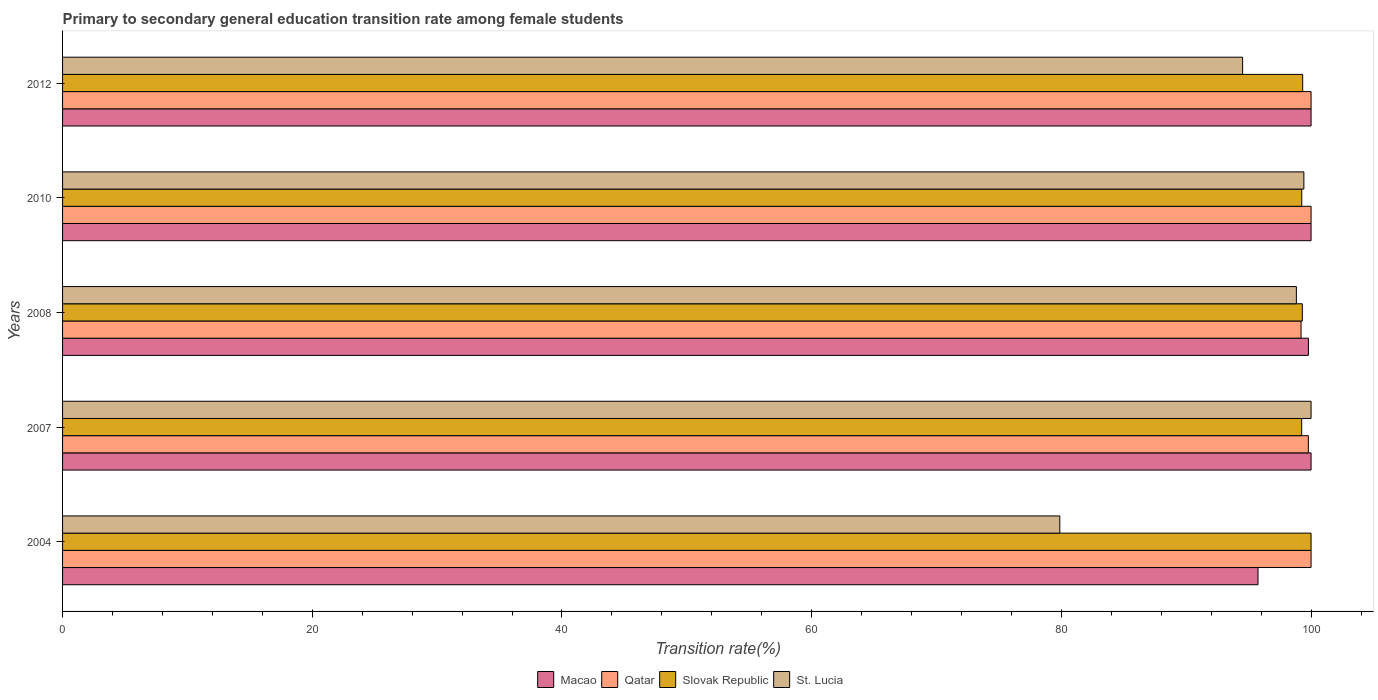Are the number of bars per tick equal to the number of legend labels?
Offer a very short reply. Yes. How many bars are there on the 1st tick from the top?
Your answer should be very brief. 4. How many bars are there on the 3rd tick from the bottom?
Provide a short and direct response. 4. What is the label of the 5th group of bars from the top?
Keep it short and to the point. 2004. In how many cases, is the number of bars for a given year not equal to the number of legend labels?
Your response must be concise. 0. What is the transition rate in Macao in 2012?
Your answer should be compact. 100. Across all years, what is the minimum transition rate in Qatar?
Ensure brevity in your answer.  99.2. In which year was the transition rate in Qatar minimum?
Offer a very short reply. 2008. What is the total transition rate in St. Lucia in the graph?
Offer a terse response. 472.64. What is the difference between the transition rate in St. Lucia in 2010 and the transition rate in Slovak Republic in 2008?
Your answer should be compact. 0.12. What is the average transition rate in St. Lucia per year?
Offer a terse response. 94.53. In the year 2010, what is the difference between the transition rate in Macao and transition rate in St. Lucia?
Make the answer very short. 0.58. In how many years, is the transition rate in Slovak Republic greater than 60 %?
Ensure brevity in your answer.  5. What is the ratio of the transition rate in St. Lucia in 2007 to that in 2010?
Ensure brevity in your answer.  1.01. What is the difference between the highest and the lowest transition rate in St. Lucia?
Give a very brief answer. 20.13. What does the 4th bar from the top in 2007 represents?
Your answer should be very brief. Macao. What does the 4th bar from the bottom in 2004 represents?
Provide a succinct answer. St. Lucia. Is it the case that in every year, the sum of the transition rate in Macao and transition rate in St. Lucia is greater than the transition rate in Qatar?
Offer a terse response. Yes. How many bars are there?
Keep it short and to the point. 20. Are the values on the major ticks of X-axis written in scientific E-notation?
Your answer should be very brief. No. Does the graph contain any zero values?
Your answer should be very brief. No. Where does the legend appear in the graph?
Your response must be concise. Bottom center. How many legend labels are there?
Offer a terse response. 4. How are the legend labels stacked?
Keep it short and to the point. Horizontal. What is the title of the graph?
Offer a very short reply. Primary to secondary general education transition rate among female students. What is the label or title of the X-axis?
Ensure brevity in your answer.  Transition rate(%). What is the label or title of the Y-axis?
Offer a terse response. Years. What is the Transition rate(%) in Macao in 2004?
Provide a short and direct response. 95.75. What is the Transition rate(%) in Slovak Republic in 2004?
Offer a very short reply. 100. What is the Transition rate(%) in St. Lucia in 2004?
Offer a very short reply. 79.87. What is the Transition rate(%) of Qatar in 2007?
Your response must be concise. 99.78. What is the Transition rate(%) in Slovak Republic in 2007?
Your answer should be very brief. 99.25. What is the Transition rate(%) in Macao in 2008?
Your answer should be very brief. 99.79. What is the Transition rate(%) in Qatar in 2008?
Provide a short and direct response. 99.2. What is the Transition rate(%) in Slovak Republic in 2008?
Your answer should be compact. 99.3. What is the Transition rate(%) of St. Lucia in 2008?
Your response must be concise. 98.82. What is the Transition rate(%) of Qatar in 2010?
Keep it short and to the point. 100. What is the Transition rate(%) in Slovak Republic in 2010?
Your answer should be compact. 99.25. What is the Transition rate(%) of St. Lucia in 2010?
Keep it short and to the point. 99.42. What is the Transition rate(%) in Qatar in 2012?
Offer a terse response. 100. What is the Transition rate(%) of Slovak Republic in 2012?
Make the answer very short. 99.33. What is the Transition rate(%) of St. Lucia in 2012?
Ensure brevity in your answer.  94.52. Across all years, what is the maximum Transition rate(%) in St. Lucia?
Offer a very short reply. 100. Across all years, what is the minimum Transition rate(%) of Macao?
Ensure brevity in your answer.  95.75. Across all years, what is the minimum Transition rate(%) of Qatar?
Offer a very short reply. 99.2. Across all years, what is the minimum Transition rate(%) in Slovak Republic?
Give a very brief answer. 99.25. Across all years, what is the minimum Transition rate(%) in St. Lucia?
Offer a terse response. 79.87. What is the total Transition rate(%) of Macao in the graph?
Offer a very short reply. 495.54. What is the total Transition rate(%) in Qatar in the graph?
Your answer should be very brief. 498.98. What is the total Transition rate(%) in Slovak Republic in the graph?
Provide a short and direct response. 497.13. What is the total Transition rate(%) in St. Lucia in the graph?
Your answer should be compact. 472.64. What is the difference between the Transition rate(%) in Macao in 2004 and that in 2007?
Your answer should be compact. -4.25. What is the difference between the Transition rate(%) of Qatar in 2004 and that in 2007?
Give a very brief answer. 0.22. What is the difference between the Transition rate(%) in Slovak Republic in 2004 and that in 2007?
Keep it short and to the point. 0.75. What is the difference between the Transition rate(%) of St. Lucia in 2004 and that in 2007?
Give a very brief answer. -20.13. What is the difference between the Transition rate(%) in Macao in 2004 and that in 2008?
Keep it short and to the point. -4.04. What is the difference between the Transition rate(%) of Qatar in 2004 and that in 2008?
Your answer should be compact. 0.8. What is the difference between the Transition rate(%) of Slovak Republic in 2004 and that in 2008?
Keep it short and to the point. 0.7. What is the difference between the Transition rate(%) of St. Lucia in 2004 and that in 2008?
Offer a terse response. -18.95. What is the difference between the Transition rate(%) of Macao in 2004 and that in 2010?
Keep it short and to the point. -4.25. What is the difference between the Transition rate(%) in Slovak Republic in 2004 and that in 2010?
Keep it short and to the point. 0.75. What is the difference between the Transition rate(%) of St. Lucia in 2004 and that in 2010?
Provide a short and direct response. -19.55. What is the difference between the Transition rate(%) in Macao in 2004 and that in 2012?
Offer a very short reply. -4.25. What is the difference between the Transition rate(%) of Slovak Republic in 2004 and that in 2012?
Your answer should be very brief. 0.67. What is the difference between the Transition rate(%) of St. Lucia in 2004 and that in 2012?
Your answer should be compact. -14.64. What is the difference between the Transition rate(%) in Macao in 2007 and that in 2008?
Offer a very short reply. 0.21. What is the difference between the Transition rate(%) of Qatar in 2007 and that in 2008?
Your answer should be very brief. 0.58. What is the difference between the Transition rate(%) in Slovak Republic in 2007 and that in 2008?
Offer a very short reply. -0.05. What is the difference between the Transition rate(%) in St. Lucia in 2007 and that in 2008?
Provide a succinct answer. 1.18. What is the difference between the Transition rate(%) in Macao in 2007 and that in 2010?
Provide a succinct answer. 0. What is the difference between the Transition rate(%) of Qatar in 2007 and that in 2010?
Make the answer very short. -0.22. What is the difference between the Transition rate(%) of Slovak Republic in 2007 and that in 2010?
Your answer should be very brief. -0.01. What is the difference between the Transition rate(%) of St. Lucia in 2007 and that in 2010?
Offer a terse response. 0.58. What is the difference between the Transition rate(%) of Qatar in 2007 and that in 2012?
Make the answer very short. -0.22. What is the difference between the Transition rate(%) of Slovak Republic in 2007 and that in 2012?
Your answer should be compact. -0.08. What is the difference between the Transition rate(%) of St. Lucia in 2007 and that in 2012?
Ensure brevity in your answer.  5.48. What is the difference between the Transition rate(%) of Macao in 2008 and that in 2010?
Give a very brief answer. -0.21. What is the difference between the Transition rate(%) of Qatar in 2008 and that in 2010?
Your answer should be very brief. -0.8. What is the difference between the Transition rate(%) in Slovak Republic in 2008 and that in 2010?
Offer a terse response. 0.05. What is the difference between the Transition rate(%) in St. Lucia in 2008 and that in 2010?
Provide a succinct answer. -0.6. What is the difference between the Transition rate(%) in Macao in 2008 and that in 2012?
Keep it short and to the point. -0.21. What is the difference between the Transition rate(%) of Qatar in 2008 and that in 2012?
Your response must be concise. -0.8. What is the difference between the Transition rate(%) in Slovak Republic in 2008 and that in 2012?
Make the answer very short. -0.03. What is the difference between the Transition rate(%) of St. Lucia in 2008 and that in 2012?
Keep it short and to the point. 4.3. What is the difference between the Transition rate(%) in Macao in 2010 and that in 2012?
Keep it short and to the point. 0. What is the difference between the Transition rate(%) of Slovak Republic in 2010 and that in 2012?
Your answer should be very brief. -0.07. What is the difference between the Transition rate(%) in St. Lucia in 2010 and that in 2012?
Make the answer very short. 4.91. What is the difference between the Transition rate(%) in Macao in 2004 and the Transition rate(%) in Qatar in 2007?
Provide a succinct answer. -4.03. What is the difference between the Transition rate(%) in Macao in 2004 and the Transition rate(%) in Slovak Republic in 2007?
Your answer should be very brief. -3.5. What is the difference between the Transition rate(%) of Macao in 2004 and the Transition rate(%) of St. Lucia in 2007?
Offer a terse response. -4.25. What is the difference between the Transition rate(%) of Qatar in 2004 and the Transition rate(%) of Slovak Republic in 2007?
Provide a succinct answer. 0.75. What is the difference between the Transition rate(%) of Qatar in 2004 and the Transition rate(%) of St. Lucia in 2007?
Your answer should be compact. 0. What is the difference between the Transition rate(%) in Slovak Republic in 2004 and the Transition rate(%) in St. Lucia in 2007?
Make the answer very short. 0. What is the difference between the Transition rate(%) of Macao in 2004 and the Transition rate(%) of Qatar in 2008?
Ensure brevity in your answer.  -3.45. What is the difference between the Transition rate(%) in Macao in 2004 and the Transition rate(%) in Slovak Republic in 2008?
Your answer should be compact. -3.55. What is the difference between the Transition rate(%) of Macao in 2004 and the Transition rate(%) of St. Lucia in 2008?
Provide a succinct answer. -3.07. What is the difference between the Transition rate(%) in Qatar in 2004 and the Transition rate(%) in Slovak Republic in 2008?
Make the answer very short. 0.7. What is the difference between the Transition rate(%) in Qatar in 2004 and the Transition rate(%) in St. Lucia in 2008?
Your response must be concise. 1.18. What is the difference between the Transition rate(%) of Slovak Republic in 2004 and the Transition rate(%) of St. Lucia in 2008?
Provide a short and direct response. 1.18. What is the difference between the Transition rate(%) in Macao in 2004 and the Transition rate(%) in Qatar in 2010?
Your answer should be compact. -4.25. What is the difference between the Transition rate(%) of Macao in 2004 and the Transition rate(%) of Slovak Republic in 2010?
Your response must be concise. -3.5. What is the difference between the Transition rate(%) in Macao in 2004 and the Transition rate(%) in St. Lucia in 2010?
Your answer should be very brief. -3.67. What is the difference between the Transition rate(%) in Qatar in 2004 and the Transition rate(%) in Slovak Republic in 2010?
Your response must be concise. 0.75. What is the difference between the Transition rate(%) of Qatar in 2004 and the Transition rate(%) of St. Lucia in 2010?
Your response must be concise. 0.58. What is the difference between the Transition rate(%) in Slovak Republic in 2004 and the Transition rate(%) in St. Lucia in 2010?
Provide a succinct answer. 0.58. What is the difference between the Transition rate(%) in Macao in 2004 and the Transition rate(%) in Qatar in 2012?
Give a very brief answer. -4.25. What is the difference between the Transition rate(%) in Macao in 2004 and the Transition rate(%) in Slovak Republic in 2012?
Your answer should be very brief. -3.58. What is the difference between the Transition rate(%) of Macao in 2004 and the Transition rate(%) of St. Lucia in 2012?
Your answer should be compact. 1.23. What is the difference between the Transition rate(%) of Qatar in 2004 and the Transition rate(%) of Slovak Republic in 2012?
Provide a short and direct response. 0.67. What is the difference between the Transition rate(%) of Qatar in 2004 and the Transition rate(%) of St. Lucia in 2012?
Your answer should be compact. 5.48. What is the difference between the Transition rate(%) of Slovak Republic in 2004 and the Transition rate(%) of St. Lucia in 2012?
Your answer should be compact. 5.48. What is the difference between the Transition rate(%) of Macao in 2007 and the Transition rate(%) of Qatar in 2008?
Make the answer very short. 0.8. What is the difference between the Transition rate(%) of Macao in 2007 and the Transition rate(%) of Slovak Republic in 2008?
Ensure brevity in your answer.  0.7. What is the difference between the Transition rate(%) in Macao in 2007 and the Transition rate(%) in St. Lucia in 2008?
Ensure brevity in your answer.  1.18. What is the difference between the Transition rate(%) of Qatar in 2007 and the Transition rate(%) of Slovak Republic in 2008?
Ensure brevity in your answer.  0.48. What is the difference between the Transition rate(%) in Qatar in 2007 and the Transition rate(%) in St. Lucia in 2008?
Provide a short and direct response. 0.96. What is the difference between the Transition rate(%) in Slovak Republic in 2007 and the Transition rate(%) in St. Lucia in 2008?
Your response must be concise. 0.43. What is the difference between the Transition rate(%) in Macao in 2007 and the Transition rate(%) in Slovak Republic in 2010?
Your answer should be very brief. 0.75. What is the difference between the Transition rate(%) in Macao in 2007 and the Transition rate(%) in St. Lucia in 2010?
Provide a succinct answer. 0.58. What is the difference between the Transition rate(%) in Qatar in 2007 and the Transition rate(%) in Slovak Republic in 2010?
Provide a short and direct response. 0.53. What is the difference between the Transition rate(%) of Qatar in 2007 and the Transition rate(%) of St. Lucia in 2010?
Your response must be concise. 0.36. What is the difference between the Transition rate(%) in Slovak Republic in 2007 and the Transition rate(%) in St. Lucia in 2010?
Offer a very short reply. -0.18. What is the difference between the Transition rate(%) of Macao in 2007 and the Transition rate(%) of Slovak Republic in 2012?
Your response must be concise. 0.67. What is the difference between the Transition rate(%) in Macao in 2007 and the Transition rate(%) in St. Lucia in 2012?
Make the answer very short. 5.48. What is the difference between the Transition rate(%) in Qatar in 2007 and the Transition rate(%) in Slovak Republic in 2012?
Keep it short and to the point. 0.45. What is the difference between the Transition rate(%) of Qatar in 2007 and the Transition rate(%) of St. Lucia in 2012?
Make the answer very short. 5.26. What is the difference between the Transition rate(%) in Slovak Republic in 2007 and the Transition rate(%) in St. Lucia in 2012?
Ensure brevity in your answer.  4.73. What is the difference between the Transition rate(%) in Macao in 2008 and the Transition rate(%) in Qatar in 2010?
Provide a succinct answer. -0.21. What is the difference between the Transition rate(%) in Macao in 2008 and the Transition rate(%) in Slovak Republic in 2010?
Ensure brevity in your answer.  0.53. What is the difference between the Transition rate(%) in Macao in 2008 and the Transition rate(%) in St. Lucia in 2010?
Make the answer very short. 0.36. What is the difference between the Transition rate(%) of Qatar in 2008 and the Transition rate(%) of Slovak Republic in 2010?
Your answer should be compact. -0.06. What is the difference between the Transition rate(%) of Qatar in 2008 and the Transition rate(%) of St. Lucia in 2010?
Offer a terse response. -0.23. What is the difference between the Transition rate(%) of Slovak Republic in 2008 and the Transition rate(%) of St. Lucia in 2010?
Make the answer very short. -0.12. What is the difference between the Transition rate(%) in Macao in 2008 and the Transition rate(%) in Qatar in 2012?
Ensure brevity in your answer.  -0.21. What is the difference between the Transition rate(%) in Macao in 2008 and the Transition rate(%) in Slovak Republic in 2012?
Your answer should be very brief. 0.46. What is the difference between the Transition rate(%) in Macao in 2008 and the Transition rate(%) in St. Lucia in 2012?
Your response must be concise. 5.27. What is the difference between the Transition rate(%) of Qatar in 2008 and the Transition rate(%) of Slovak Republic in 2012?
Give a very brief answer. -0.13. What is the difference between the Transition rate(%) in Qatar in 2008 and the Transition rate(%) in St. Lucia in 2012?
Your response must be concise. 4.68. What is the difference between the Transition rate(%) of Slovak Republic in 2008 and the Transition rate(%) of St. Lucia in 2012?
Provide a succinct answer. 4.78. What is the difference between the Transition rate(%) of Macao in 2010 and the Transition rate(%) of Slovak Republic in 2012?
Offer a very short reply. 0.67. What is the difference between the Transition rate(%) in Macao in 2010 and the Transition rate(%) in St. Lucia in 2012?
Offer a terse response. 5.48. What is the difference between the Transition rate(%) in Qatar in 2010 and the Transition rate(%) in Slovak Republic in 2012?
Offer a terse response. 0.67. What is the difference between the Transition rate(%) of Qatar in 2010 and the Transition rate(%) of St. Lucia in 2012?
Keep it short and to the point. 5.48. What is the difference between the Transition rate(%) in Slovak Republic in 2010 and the Transition rate(%) in St. Lucia in 2012?
Give a very brief answer. 4.74. What is the average Transition rate(%) in Macao per year?
Offer a terse response. 99.11. What is the average Transition rate(%) in Qatar per year?
Make the answer very short. 99.8. What is the average Transition rate(%) of Slovak Republic per year?
Ensure brevity in your answer.  99.43. What is the average Transition rate(%) of St. Lucia per year?
Your answer should be compact. 94.53. In the year 2004, what is the difference between the Transition rate(%) of Macao and Transition rate(%) of Qatar?
Ensure brevity in your answer.  -4.25. In the year 2004, what is the difference between the Transition rate(%) of Macao and Transition rate(%) of Slovak Republic?
Give a very brief answer. -4.25. In the year 2004, what is the difference between the Transition rate(%) of Macao and Transition rate(%) of St. Lucia?
Provide a succinct answer. 15.88. In the year 2004, what is the difference between the Transition rate(%) in Qatar and Transition rate(%) in Slovak Republic?
Make the answer very short. 0. In the year 2004, what is the difference between the Transition rate(%) in Qatar and Transition rate(%) in St. Lucia?
Provide a short and direct response. 20.13. In the year 2004, what is the difference between the Transition rate(%) in Slovak Republic and Transition rate(%) in St. Lucia?
Give a very brief answer. 20.13. In the year 2007, what is the difference between the Transition rate(%) in Macao and Transition rate(%) in Qatar?
Your answer should be very brief. 0.22. In the year 2007, what is the difference between the Transition rate(%) in Macao and Transition rate(%) in Slovak Republic?
Make the answer very short. 0.75. In the year 2007, what is the difference between the Transition rate(%) in Macao and Transition rate(%) in St. Lucia?
Provide a short and direct response. 0. In the year 2007, what is the difference between the Transition rate(%) of Qatar and Transition rate(%) of Slovak Republic?
Make the answer very short. 0.53. In the year 2007, what is the difference between the Transition rate(%) in Qatar and Transition rate(%) in St. Lucia?
Your answer should be compact. -0.22. In the year 2007, what is the difference between the Transition rate(%) in Slovak Republic and Transition rate(%) in St. Lucia?
Provide a succinct answer. -0.75. In the year 2008, what is the difference between the Transition rate(%) in Macao and Transition rate(%) in Qatar?
Your answer should be very brief. 0.59. In the year 2008, what is the difference between the Transition rate(%) in Macao and Transition rate(%) in Slovak Republic?
Give a very brief answer. 0.49. In the year 2008, what is the difference between the Transition rate(%) of Macao and Transition rate(%) of St. Lucia?
Provide a short and direct response. 0.97. In the year 2008, what is the difference between the Transition rate(%) in Qatar and Transition rate(%) in Slovak Republic?
Offer a terse response. -0.1. In the year 2008, what is the difference between the Transition rate(%) of Qatar and Transition rate(%) of St. Lucia?
Your answer should be compact. 0.38. In the year 2008, what is the difference between the Transition rate(%) of Slovak Republic and Transition rate(%) of St. Lucia?
Offer a terse response. 0.48. In the year 2010, what is the difference between the Transition rate(%) of Macao and Transition rate(%) of Qatar?
Keep it short and to the point. 0. In the year 2010, what is the difference between the Transition rate(%) in Macao and Transition rate(%) in Slovak Republic?
Offer a terse response. 0.75. In the year 2010, what is the difference between the Transition rate(%) in Macao and Transition rate(%) in St. Lucia?
Give a very brief answer. 0.58. In the year 2010, what is the difference between the Transition rate(%) of Qatar and Transition rate(%) of Slovak Republic?
Your answer should be very brief. 0.75. In the year 2010, what is the difference between the Transition rate(%) in Qatar and Transition rate(%) in St. Lucia?
Give a very brief answer. 0.58. In the year 2010, what is the difference between the Transition rate(%) of Slovak Republic and Transition rate(%) of St. Lucia?
Your answer should be very brief. -0.17. In the year 2012, what is the difference between the Transition rate(%) in Macao and Transition rate(%) in Slovak Republic?
Provide a short and direct response. 0.67. In the year 2012, what is the difference between the Transition rate(%) in Macao and Transition rate(%) in St. Lucia?
Provide a short and direct response. 5.48. In the year 2012, what is the difference between the Transition rate(%) in Qatar and Transition rate(%) in Slovak Republic?
Make the answer very short. 0.67. In the year 2012, what is the difference between the Transition rate(%) of Qatar and Transition rate(%) of St. Lucia?
Your response must be concise. 5.48. In the year 2012, what is the difference between the Transition rate(%) of Slovak Republic and Transition rate(%) of St. Lucia?
Provide a succinct answer. 4.81. What is the ratio of the Transition rate(%) of Macao in 2004 to that in 2007?
Your answer should be compact. 0.96. What is the ratio of the Transition rate(%) in Qatar in 2004 to that in 2007?
Ensure brevity in your answer.  1. What is the ratio of the Transition rate(%) of Slovak Republic in 2004 to that in 2007?
Offer a very short reply. 1.01. What is the ratio of the Transition rate(%) of St. Lucia in 2004 to that in 2007?
Ensure brevity in your answer.  0.8. What is the ratio of the Transition rate(%) of Macao in 2004 to that in 2008?
Your response must be concise. 0.96. What is the ratio of the Transition rate(%) of Slovak Republic in 2004 to that in 2008?
Provide a short and direct response. 1.01. What is the ratio of the Transition rate(%) in St. Lucia in 2004 to that in 2008?
Offer a terse response. 0.81. What is the ratio of the Transition rate(%) in Macao in 2004 to that in 2010?
Provide a succinct answer. 0.96. What is the ratio of the Transition rate(%) in Qatar in 2004 to that in 2010?
Provide a short and direct response. 1. What is the ratio of the Transition rate(%) in Slovak Republic in 2004 to that in 2010?
Your answer should be very brief. 1.01. What is the ratio of the Transition rate(%) of St. Lucia in 2004 to that in 2010?
Offer a terse response. 0.8. What is the ratio of the Transition rate(%) in Macao in 2004 to that in 2012?
Offer a terse response. 0.96. What is the ratio of the Transition rate(%) of Slovak Republic in 2004 to that in 2012?
Ensure brevity in your answer.  1.01. What is the ratio of the Transition rate(%) in St. Lucia in 2004 to that in 2012?
Offer a very short reply. 0.85. What is the ratio of the Transition rate(%) of Macao in 2007 to that in 2008?
Keep it short and to the point. 1. What is the ratio of the Transition rate(%) of Qatar in 2007 to that in 2008?
Offer a terse response. 1.01. What is the ratio of the Transition rate(%) of St. Lucia in 2007 to that in 2008?
Your answer should be compact. 1.01. What is the ratio of the Transition rate(%) in St. Lucia in 2007 to that in 2010?
Provide a succinct answer. 1.01. What is the ratio of the Transition rate(%) of St. Lucia in 2007 to that in 2012?
Keep it short and to the point. 1.06. What is the ratio of the Transition rate(%) in Slovak Republic in 2008 to that in 2010?
Your answer should be compact. 1. What is the ratio of the Transition rate(%) of Macao in 2008 to that in 2012?
Offer a terse response. 1. What is the ratio of the Transition rate(%) of St. Lucia in 2008 to that in 2012?
Provide a succinct answer. 1.05. What is the ratio of the Transition rate(%) of Macao in 2010 to that in 2012?
Provide a short and direct response. 1. What is the ratio of the Transition rate(%) of Qatar in 2010 to that in 2012?
Keep it short and to the point. 1. What is the ratio of the Transition rate(%) in St. Lucia in 2010 to that in 2012?
Your answer should be compact. 1.05. What is the difference between the highest and the second highest Transition rate(%) in Qatar?
Offer a very short reply. 0. What is the difference between the highest and the second highest Transition rate(%) of Slovak Republic?
Offer a terse response. 0.67. What is the difference between the highest and the second highest Transition rate(%) of St. Lucia?
Keep it short and to the point. 0.58. What is the difference between the highest and the lowest Transition rate(%) of Macao?
Provide a short and direct response. 4.25. What is the difference between the highest and the lowest Transition rate(%) in Qatar?
Keep it short and to the point. 0.8. What is the difference between the highest and the lowest Transition rate(%) in Slovak Republic?
Your response must be concise. 0.75. What is the difference between the highest and the lowest Transition rate(%) in St. Lucia?
Provide a short and direct response. 20.13. 